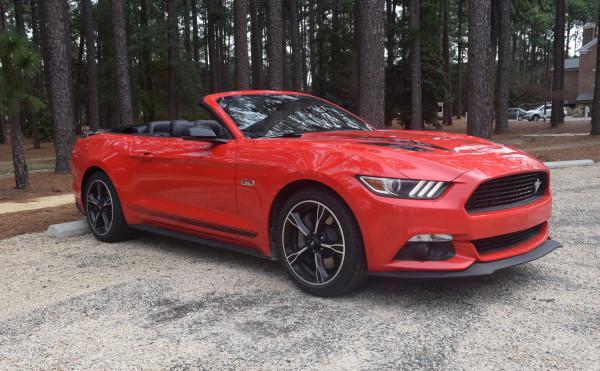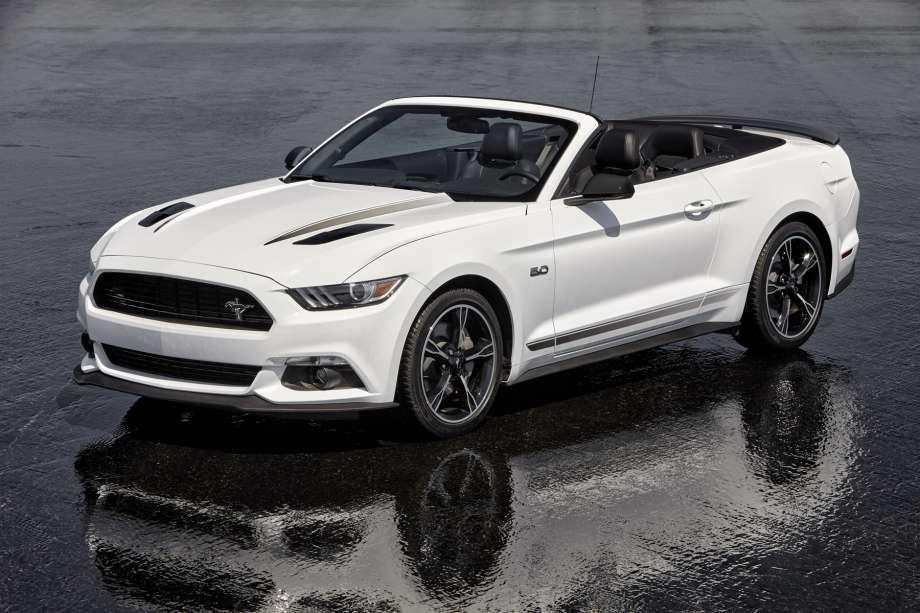The first image is the image on the left, the second image is the image on the right. Given the left and right images, does the statement "A red convertible is displayed at an angle on pavement in the left image, while the right image shows a white convertible." hold true? Answer yes or no. Yes. The first image is the image on the left, the second image is the image on the right. Examine the images to the left and right. Is the description "A red convertible with the top down is shown in the left image on a paved surface" accurate? Answer yes or no. Yes. 